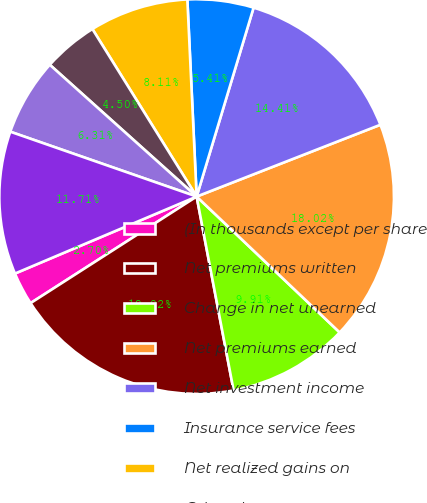<chart> <loc_0><loc_0><loc_500><loc_500><pie_chart><fcel>(In thousands except per share<fcel>Net premiums written<fcel>Change in net unearned<fcel>Net premiums earned<fcel>Net investment income<fcel>Insurance service fees<fcel>Net realized gains on<fcel>Other-than-temporary<fcel>Net investment gains<fcel>Revenues from wholly-owned<nl><fcel>2.7%<fcel>18.92%<fcel>9.91%<fcel>18.02%<fcel>14.41%<fcel>5.41%<fcel>8.11%<fcel>4.5%<fcel>6.31%<fcel>11.71%<nl></chart> 